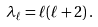<formula> <loc_0><loc_0><loc_500><loc_500>\lambda _ { \ell } = \ell ( \ell + 2 ) \, .</formula> 